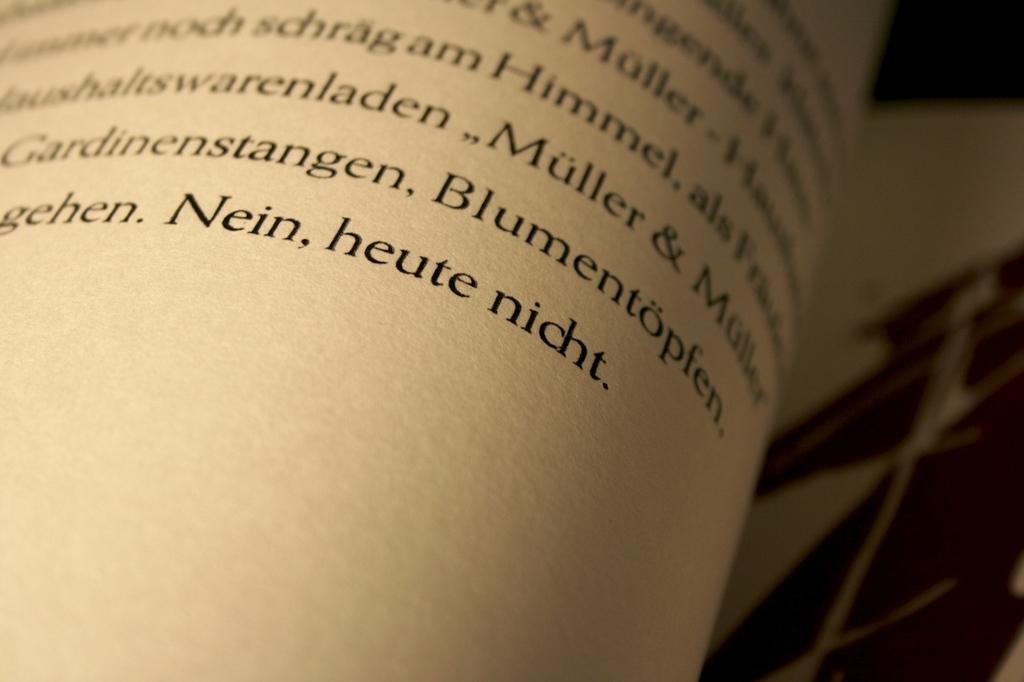Provide a one-sentence caption for the provided image. Looking at a book in foreign language with a magnifying glass. 